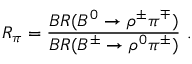Convert formula to latex. <formula><loc_0><loc_0><loc_500><loc_500>R _ { \pi } = \frac { B R ( B ^ { 0 } \rightarrow \rho ^ { \pm } \pi ^ { \mp } ) } { B R ( B ^ { \pm } \rightarrow \rho ^ { 0 } \pi ^ { \pm } ) } \ .</formula> 